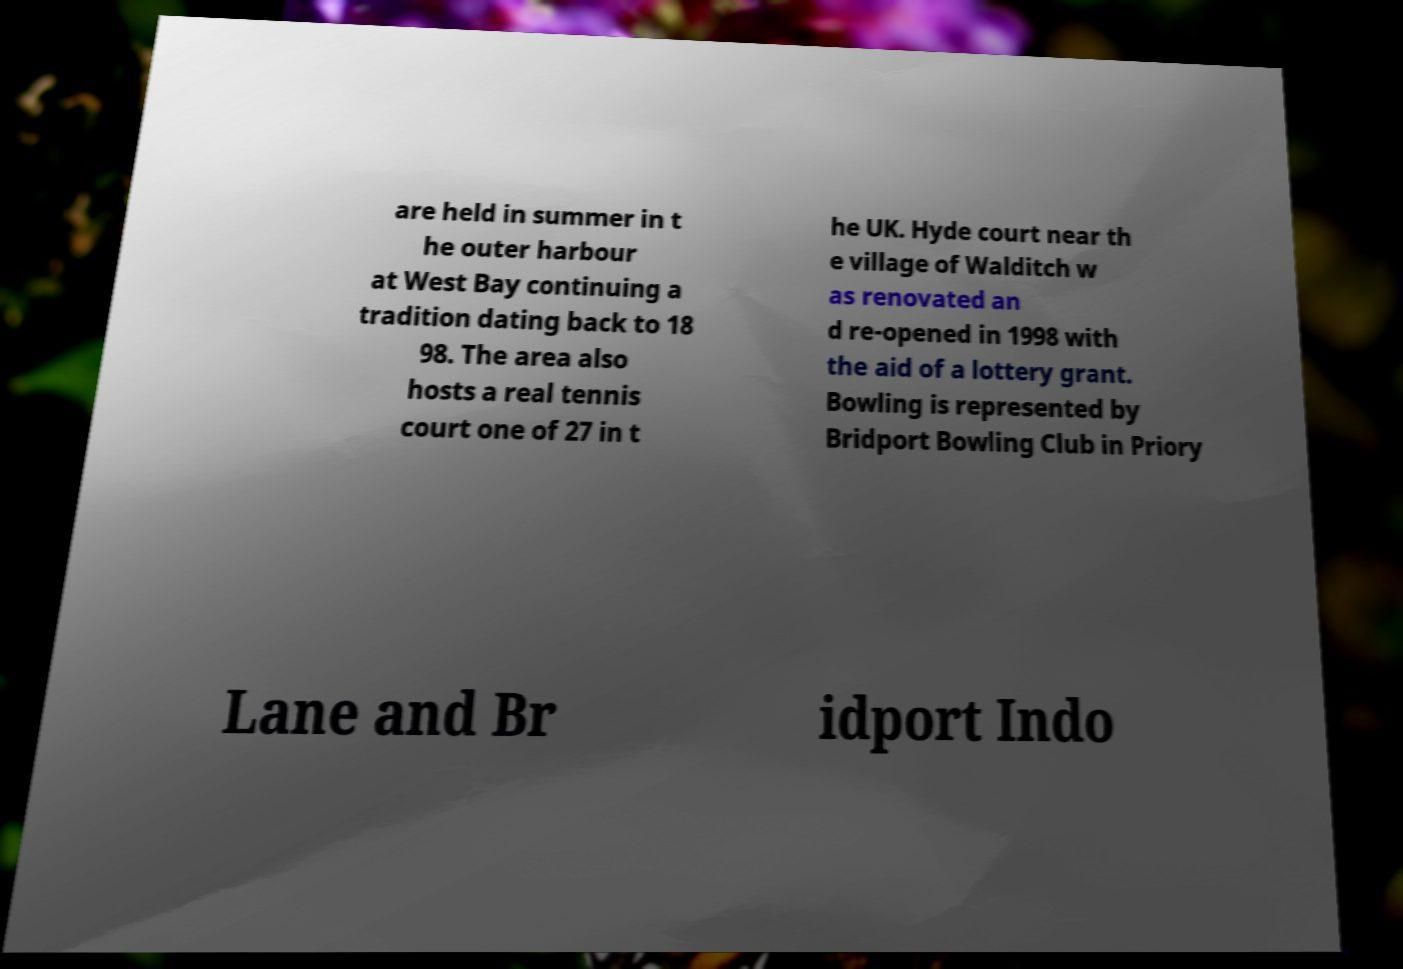Could you assist in decoding the text presented in this image and type it out clearly? are held in summer in t he outer harbour at West Bay continuing a tradition dating back to 18 98. The area also hosts a real tennis court one of 27 in t he UK. Hyde court near th e village of Walditch w as renovated an d re-opened in 1998 with the aid of a lottery grant. Bowling is represented by Bridport Bowling Club in Priory Lane and Br idport Indo 